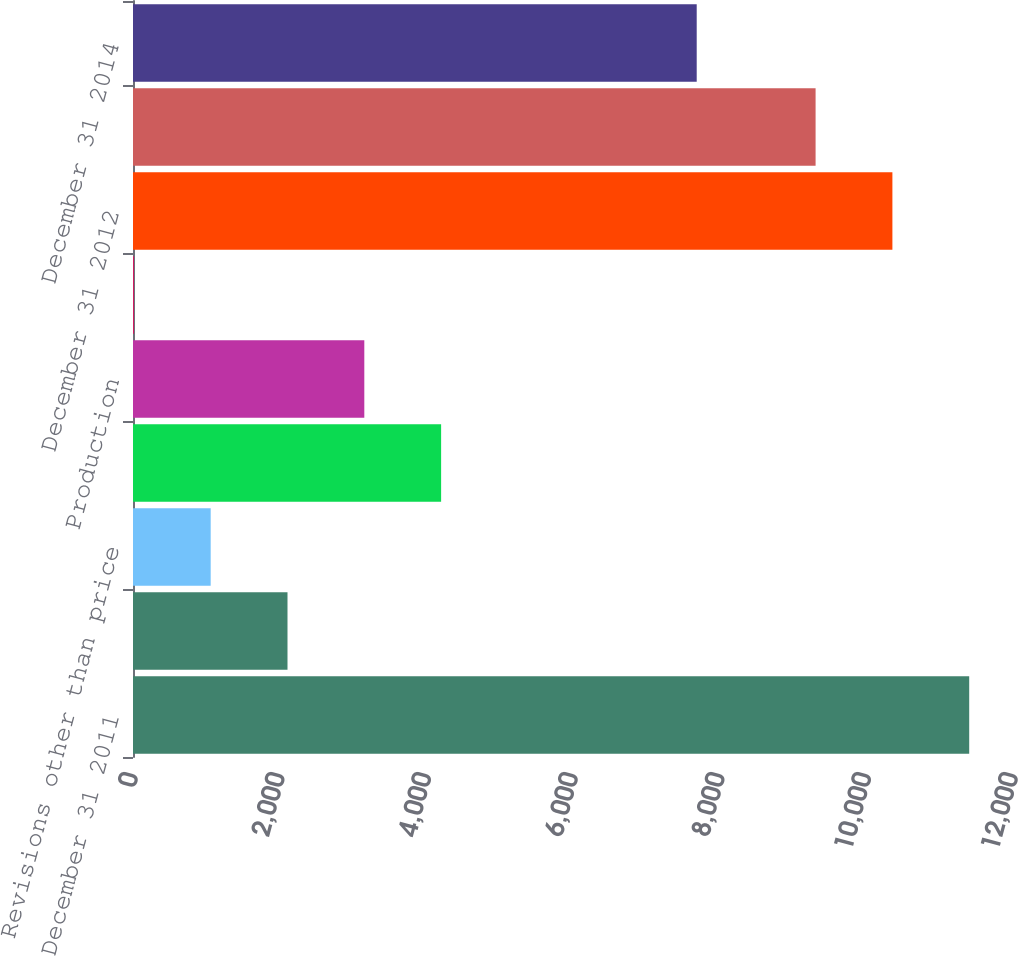Convert chart to OTSL. <chart><loc_0><loc_0><loc_500><loc_500><bar_chart><fcel>December 31 2011<fcel>Revisions due to prices<fcel>Revisions other than price<fcel>Extensions and discoveries<fcel>Production<fcel>Sale of reserves<fcel>December 31 2012<fcel>December 31 2013<fcel>December 31 2014<nl><fcel>11402.8<fcel>2106.8<fcel>1059.4<fcel>4201.6<fcel>3154.2<fcel>12<fcel>10355.4<fcel>9308<fcel>7687<nl></chart> 